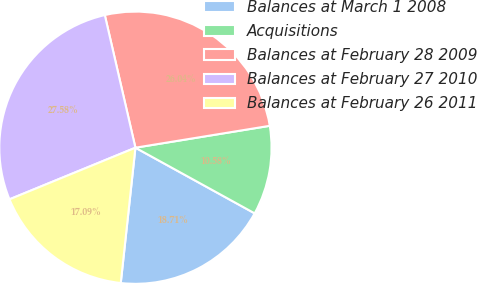Convert chart. <chart><loc_0><loc_0><loc_500><loc_500><pie_chart><fcel>Balances at March 1 2008<fcel>Acquisitions<fcel>Balances at February 28 2009<fcel>Balances at February 27 2010<fcel>Balances at February 26 2011<nl><fcel>18.71%<fcel>10.58%<fcel>26.04%<fcel>27.58%<fcel>17.09%<nl></chart> 